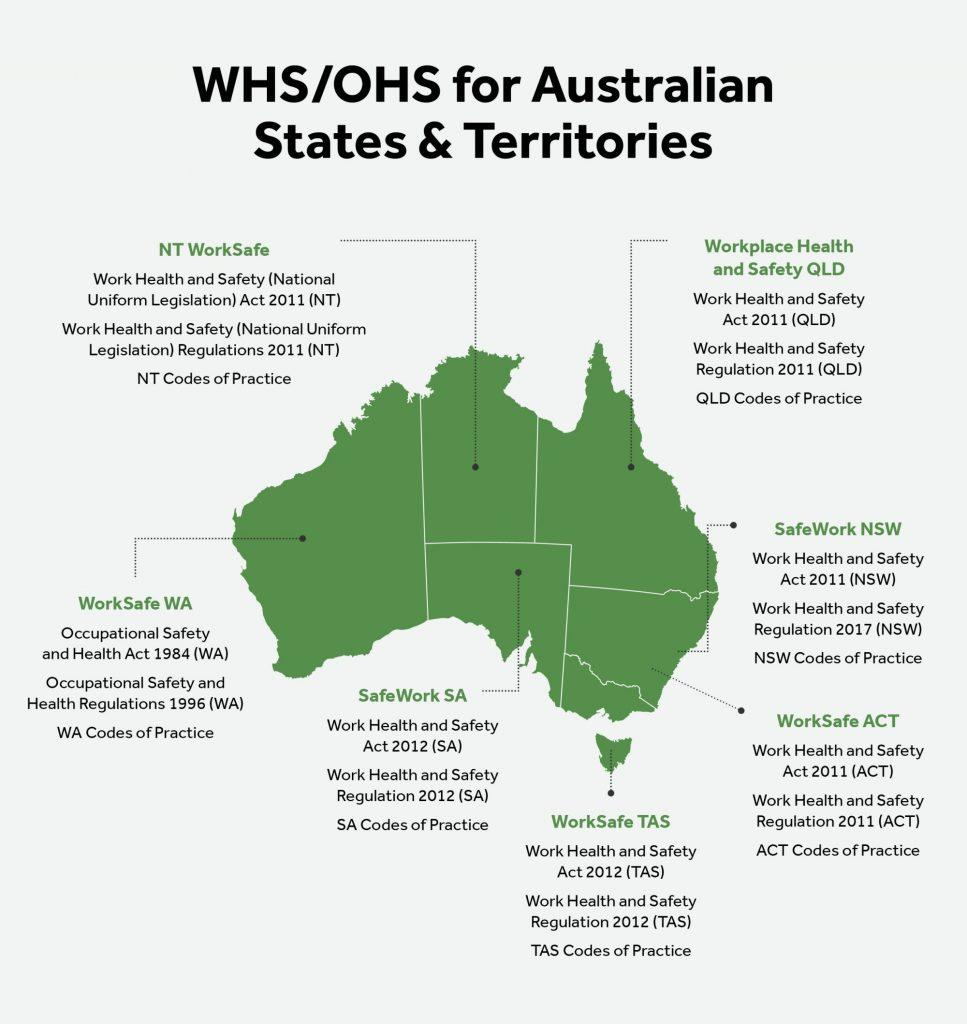Draw attention to some important aspects in this diagram. There are a total of 7 Work Health and Safety (WHS) and Occupational Health and Safety (OHS) laws listed for all Australian states and territories. There are 3 listed WorkSafe ACT regulations regarding workplace health and safety. 